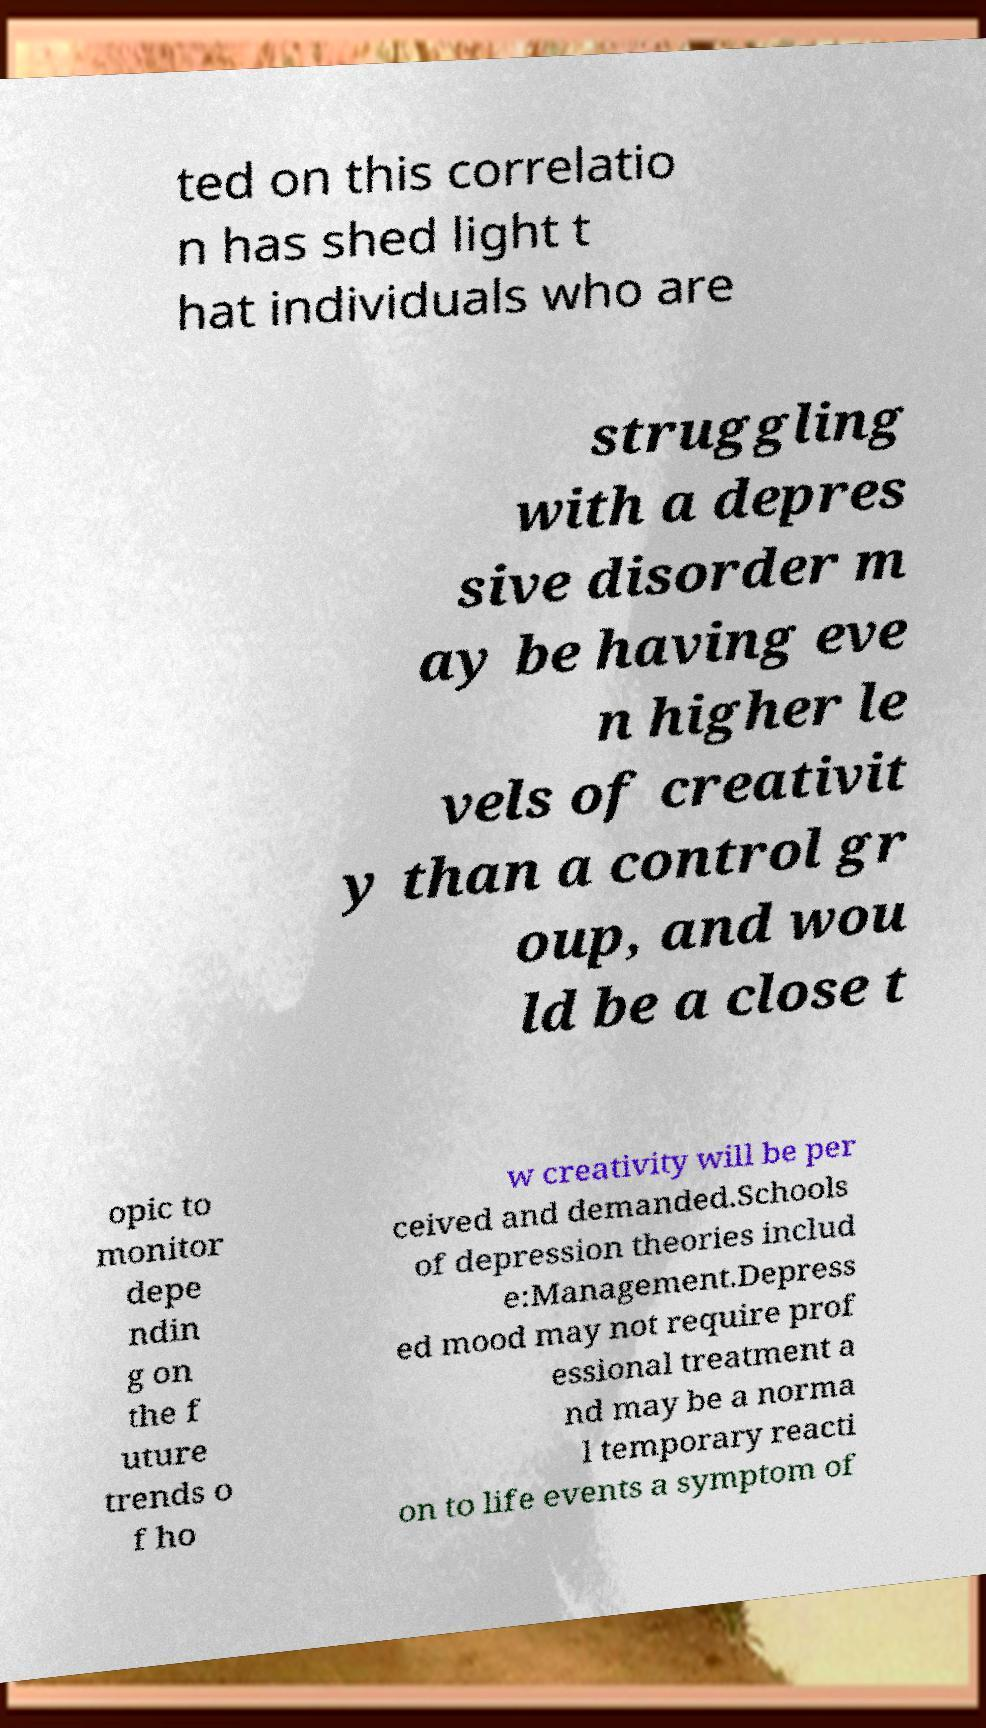There's text embedded in this image that I need extracted. Can you transcribe it verbatim? ted on this correlatio n has shed light t hat individuals who are struggling with a depres sive disorder m ay be having eve n higher le vels of creativit y than a control gr oup, and wou ld be a close t opic to monitor depe ndin g on the f uture trends o f ho w creativity will be per ceived and demanded.Schools of depression theories includ e:Management.Depress ed mood may not require prof essional treatment a nd may be a norma l temporary reacti on to life events a symptom of 